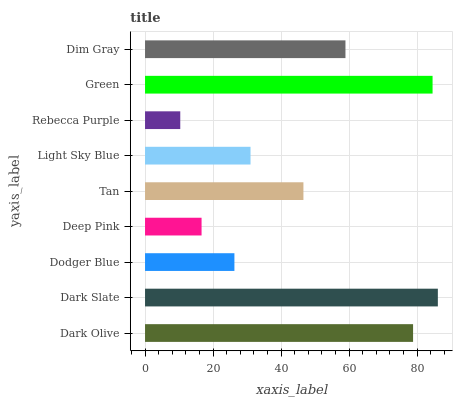Is Rebecca Purple the minimum?
Answer yes or no. Yes. Is Dark Slate the maximum?
Answer yes or no. Yes. Is Dodger Blue the minimum?
Answer yes or no. No. Is Dodger Blue the maximum?
Answer yes or no. No. Is Dark Slate greater than Dodger Blue?
Answer yes or no. Yes. Is Dodger Blue less than Dark Slate?
Answer yes or no. Yes. Is Dodger Blue greater than Dark Slate?
Answer yes or no. No. Is Dark Slate less than Dodger Blue?
Answer yes or no. No. Is Tan the high median?
Answer yes or no. Yes. Is Tan the low median?
Answer yes or no. Yes. Is Green the high median?
Answer yes or no. No. Is Green the low median?
Answer yes or no. No. 